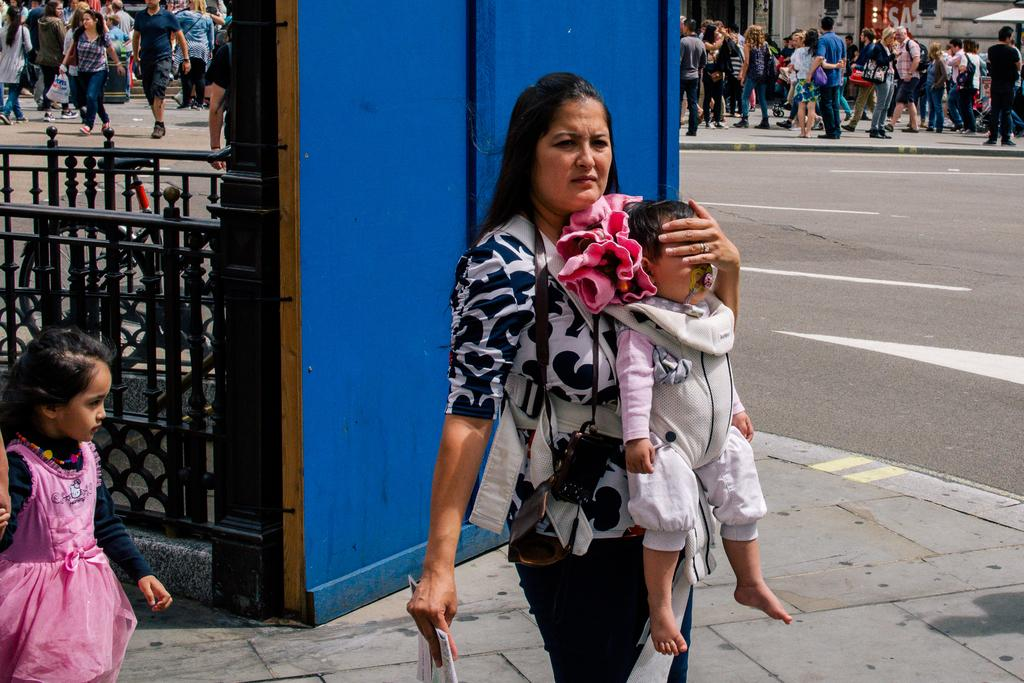What is the woman in the image doing? The woman is holding an object and carrying a baby. Can you describe the girl in the image? There is a girl in the image, but no specific details about her are provided. What can be seen beside the girl? There is a grill beside the girl. What color is the wall in the background? The wall in the background is blue. Are there any other people visible in the image? Yes, there are people visible in the distance. What type of meat is being cooked on the grill in the image? There is no meat visible in the image, and the grill is beside the girl, not being used. What hope does the woman have for the future in the image? The image does not provide any information about the woman's hopes or future plans. 